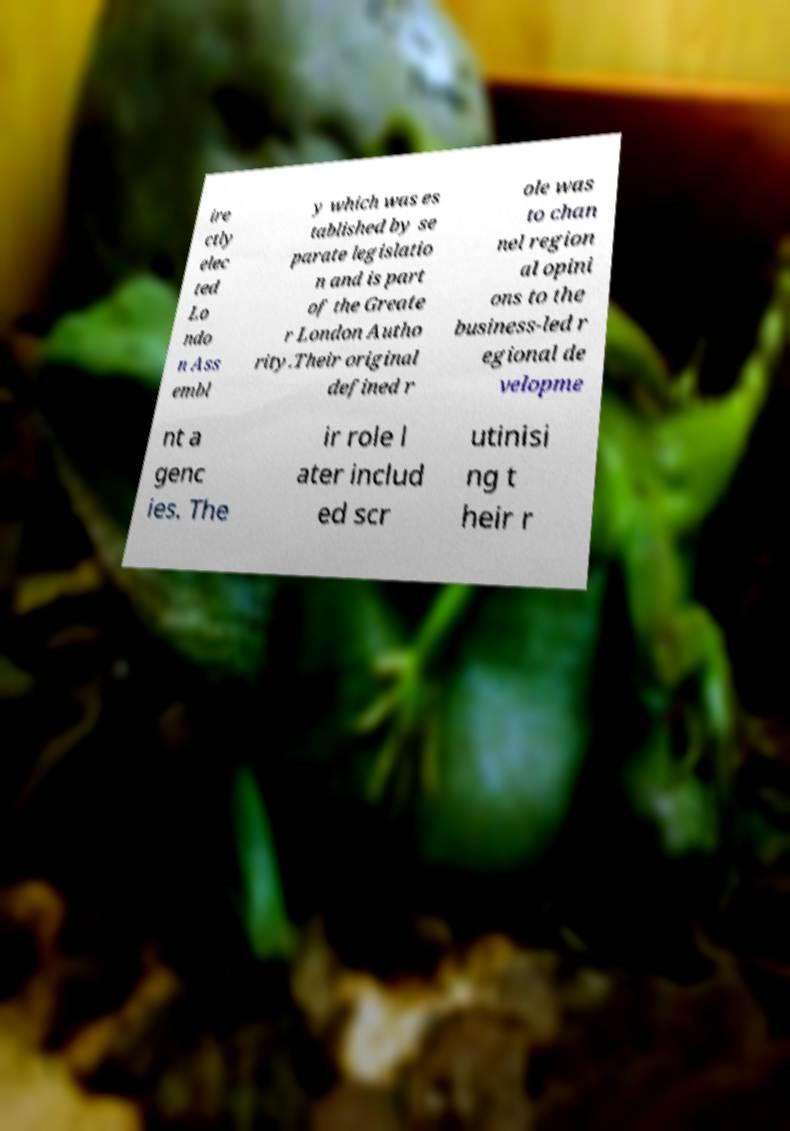There's text embedded in this image that I need extracted. Can you transcribe it verbatim? ire ctly elec ted Lo ndo n Ass embl y which was es tablished by se parate legislatio n and is part of the Greate r London Autho rity.Their original defined r ole was to chan nel region al opini ons to the business-led r egional de velopme nt a genc ies. The ir role l ater includ ed scr utinisi ng t heir r 